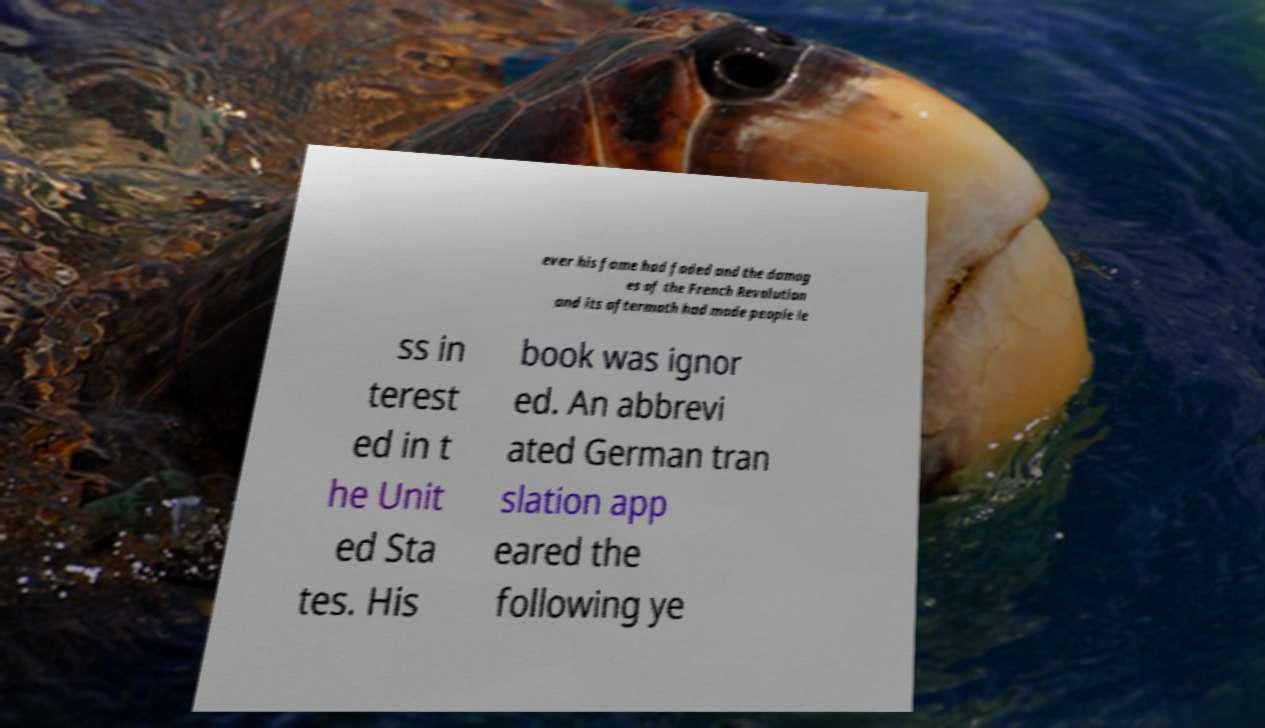Can you read and provide the text displayed in the image?This photo seems to have some interesting text. Can you extract and type it out for me? ever his fame had faded and the damag es of the French Revolution and its aftermath had made people le ss in terest ed in t he Unit ed Sta tes. His book was ignor ed. An abbrevi ated German tran slation app eared the following ye 